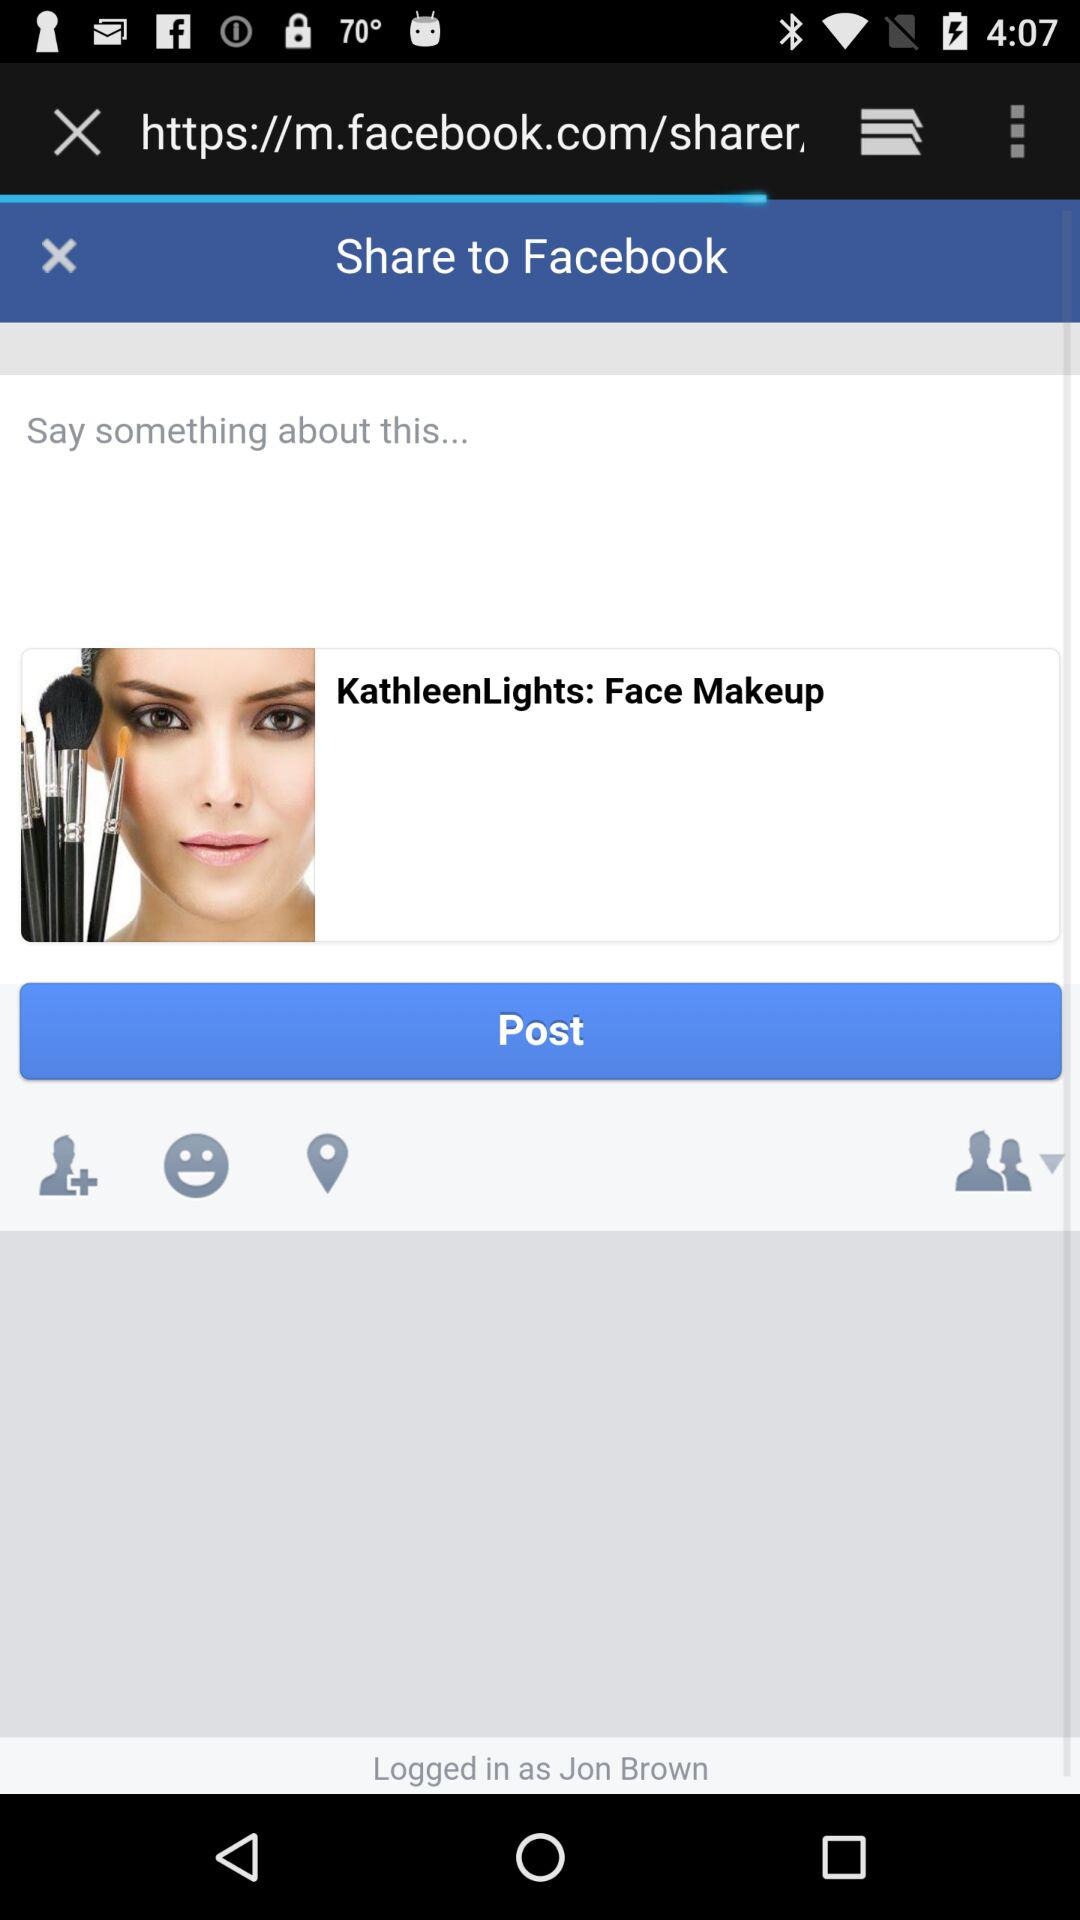What is the application name? The application name is "Facebook". 